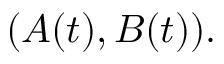Convert formula to latex. <formula><loc_0><loc_0><loc_500><loc_500>( A ( t ) , B ( t ) ) .</formula> 